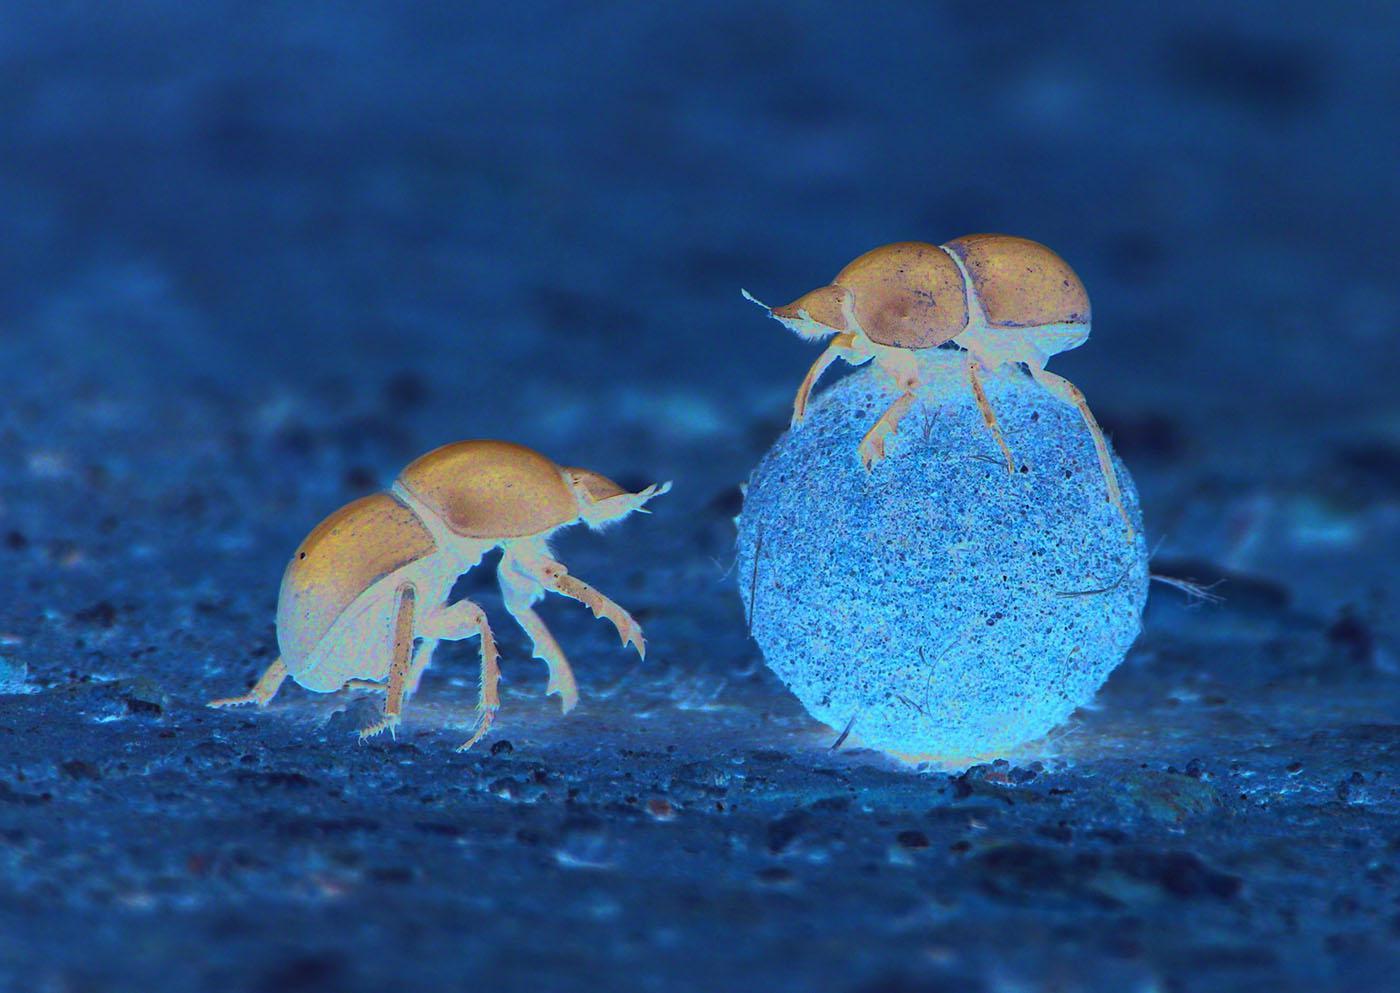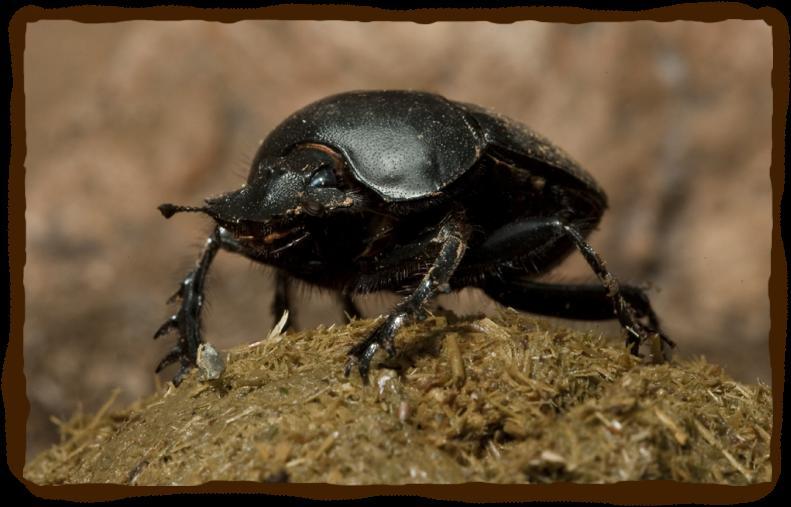The first image is the image on the left, the second image is the image on the right. Assess this claim about the two images: "One image does not include a dungball with the beetle.". Correct or not? Answer yes or no. No. 